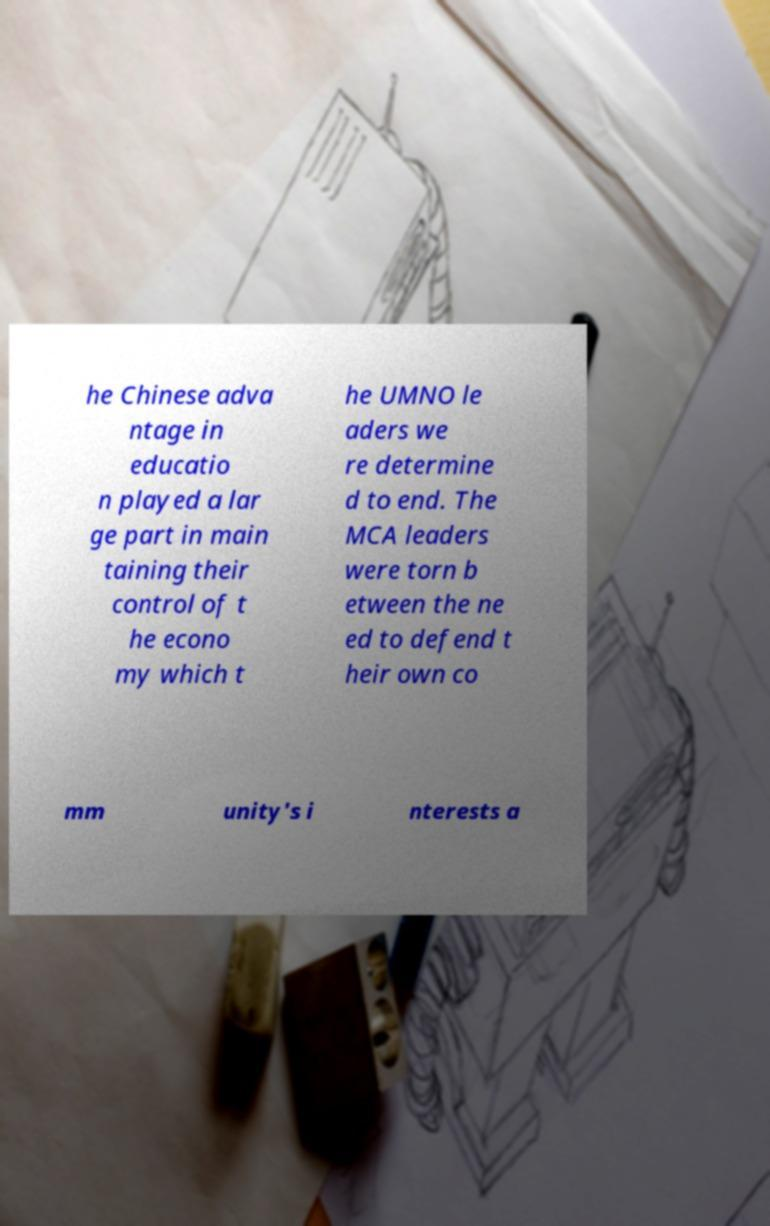Could you assist in decoding the text presented in this image and type it out clearly? he Chinese adva ntage in educatio n played a lar ge part in main taining their control of t he econo my which t he UMNO le aders we re determine d to end. The MCA leaders were torn b etween the ne ed to defend t heir own co mm unity's i nterests a 